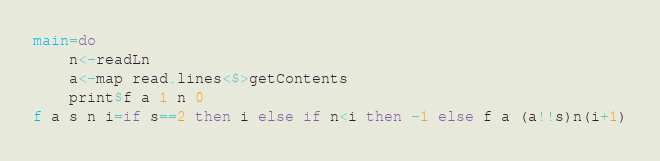Convert code to text. <code><loc_0><loc_0><loc_500><loc_500><_Haskell_>main=do
	n<-readLn
	a<-map read.lines<$>getContents
	print$f a 1 n 0
f a s n i=if s==2 then i else if n<i then -1 else f a (a!!s)n(i+1)</code> 